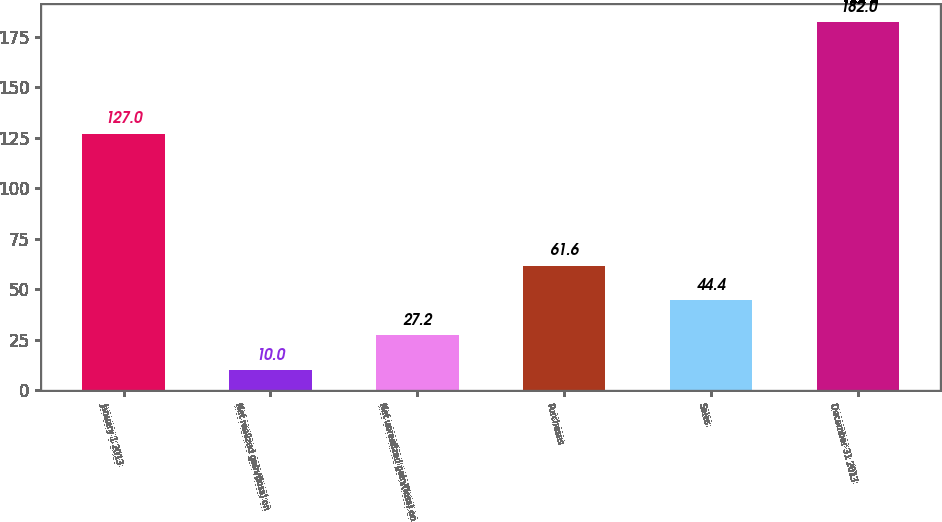Convert chart. <chart><loc_0><loc_0><loc_500><loc_500><bar_chart><fcel>January 1 2013<fcel>Net realized gain/(loss) on<fcel>Net unrealized gain/(loss) on<fcel>Purchases<fcel>Sales<fcel>December 31 2013<nl><fcel>127<fcel>10<fcel>27.2<fcel>61.6<fcel>44.4<fcel>182<nl></chart> 